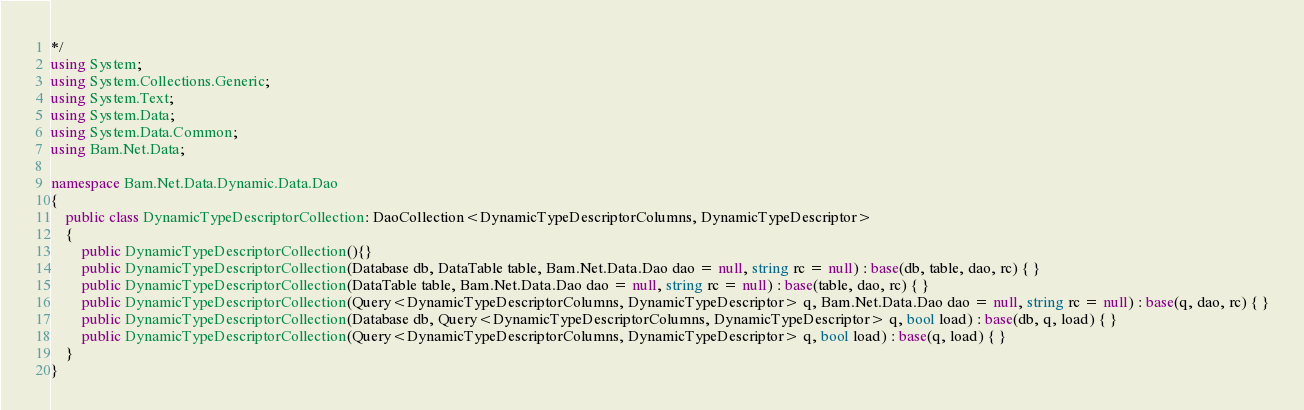Convert code to text. <code><loc_0><loc_0><loc_500><loc_500><_C#_>*/
using System;
using System.Collections.Generic;
using System.Text;
using System.Data;
using System.Data.Common;
using Bam.Net.Data;

namespace Bam.Net.Data.Dynamic.Data.Dao
{
    public class DynamicTypeDescriptorCollection: DaoCollection<DynamicTypeDescriptorColumns, DynamicTypeDescriptor>
    { 
		public DynamicTypeDescriptorCollection(){}
		public DynamicTypeDescriptorCollection(Database db, DataTable table, Bam.Net.Data.Dao dao = null, string rc = null) : base(db, table, dao, rc) { }
		public DynamicTypeDescriptorCollection(DataTable table, Bam.Net.Data.Dao dao = null, string rc = null) : base(table, dao, rc) { }
		public DynamicTypeDescriptorCollection(Query<DynamicTypeDescriptorColumns, DynamicTypeDescriptor> q, Bam.Net.Data.Dao dao = null, string rc = null) : base(q, dao, rc) { }
		public DynamicTypeDescriptorCollection(Database db, Query<DynamicTypeDescriptorColumns, DynamicTypeDescriptor> q, bool load) : base(db, q, load) { }
		public DynamicTypeDescriptorCollection(Query<DynamicTypeDescriptorColumns, DynamicTypeDescriptor> q, bool load) : base(q, load) { }
    }
}</code> 